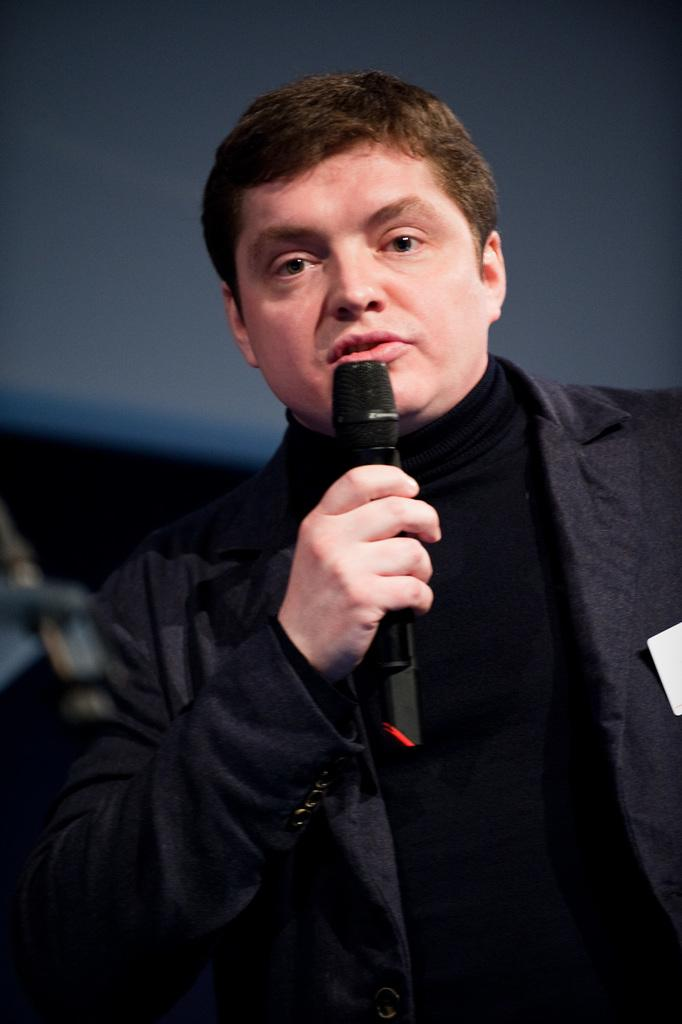What color is the shirt that the person in the image is wearing? The person in the image is wearing a black shirt. What type of clothing is worn over the shirt? The person is wearing a black blazer over the shirt. What is the person holding in their hand? The person is holding a microphone in their hand. What is the person doing in the image? The person is talking. How would you describe the background of the background of the image? The background of the image is blurry. Can you see any nests in the background of the image? There are no nests visible in the image; the background is blurry. 